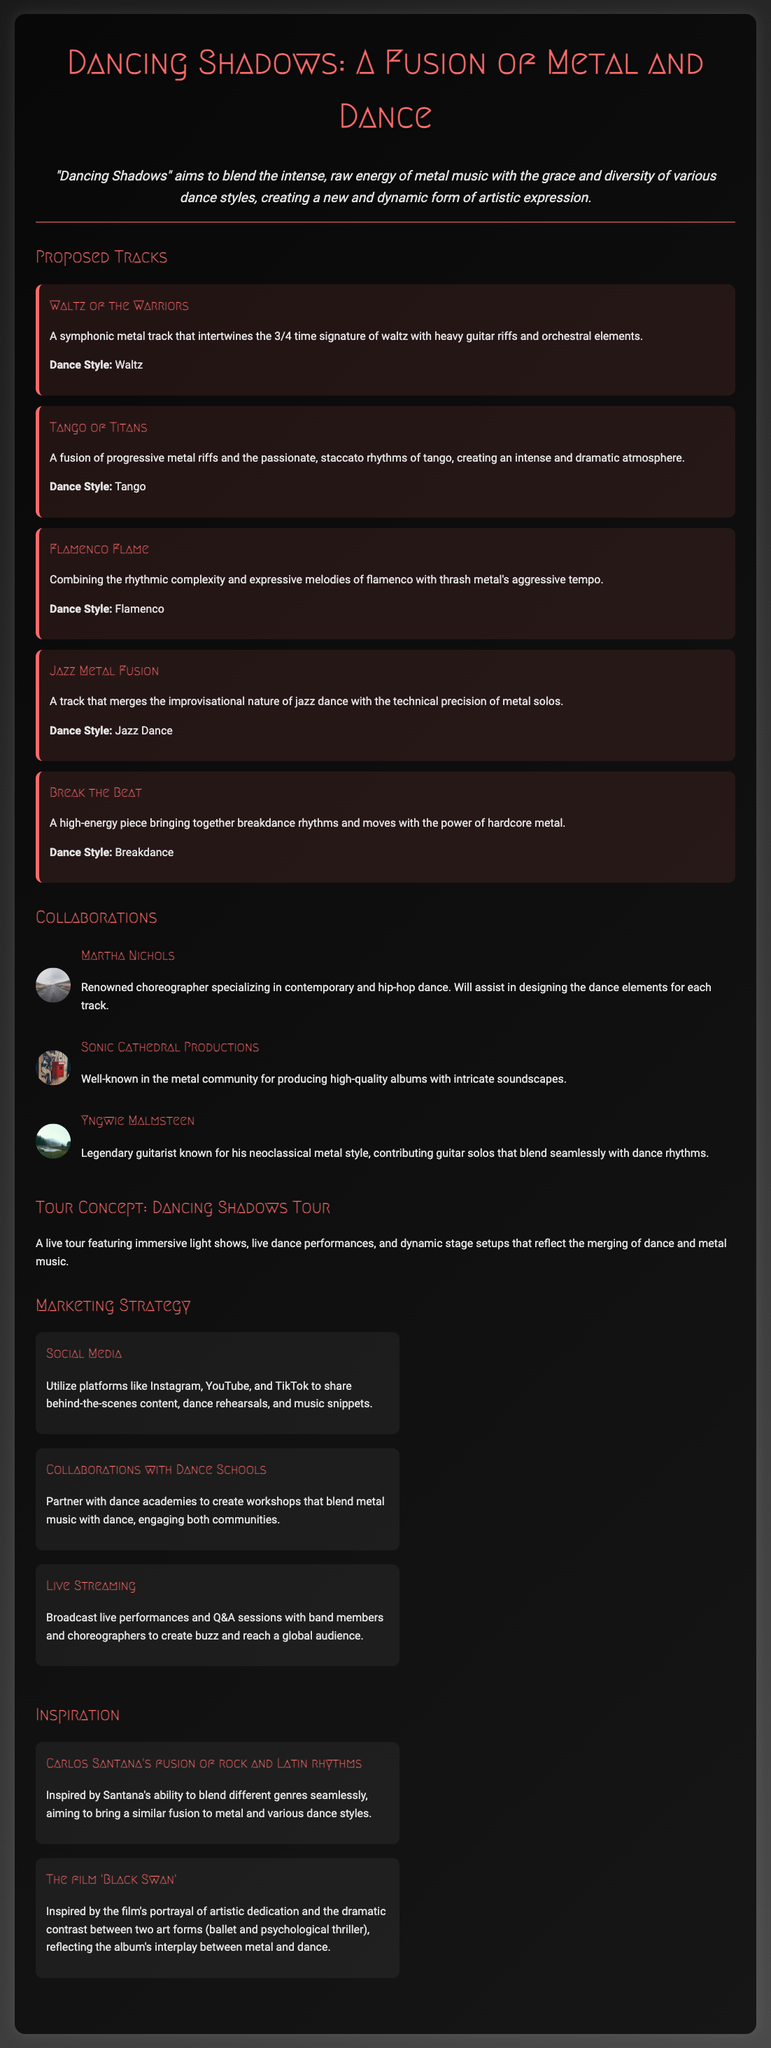What is the title of the proposal? The title of the proposal is prominently displayed at the top of the document, which is "Dancing Shadows: A Fusion of Metal and Dance."
Answer: Dancing Shadows: A Fusion of Metal and Dance How many proposed tracks are listed in the document? The number of proposed tracks can be counted in the "Proposed Tracks" section, where five tracks are mentioned.
Answer: Five What is the main dance style for the track "Flamenco Flame"? The specific dance style for the track "Flamenco Flame" is listed in its description in the "Proposed Tracks" section.
Answer: Flamenco Who is the renowned choreographer mentioned in the collaborations? The document includes the name of a renowned choreographer who will assist with the dance elements for each track.
Answer: Martha Nichols What is the inspiration derived from the film "Black Swan"? The document explains how the film "Black Swan" influences the album's themes, especially in the contrast of artistic forms.
Answer: Interplay between metal and dance What marketing strategy involves partnering with dance academies? This specific marketing strategy focuses on creating workshops that connect the metal music community with dance.
Answer: Collaborations with Dance Schools In what year is the concept album "Dancing Shadows" proposed? The document does not specifically mention a year for the proposal of the album.
Answer: Not specified What kind of light shows are planned for the "Dancing Shadows Tour"? The description of the tour concept indicates an immersive experience combining various artistic elements.
Answer: Immersive light shows 